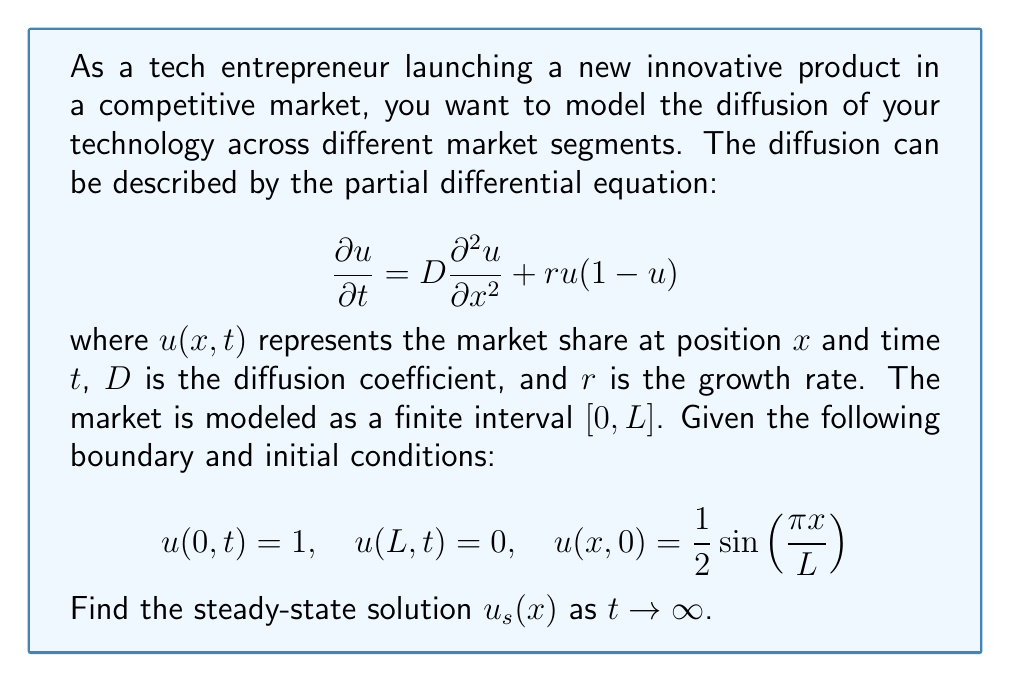Teach me how to tackle this problem. To solve this boundary value problem and find the steady-state solution, we follow these steps:

1) In the steady state, $\frac{\partial u}{\partial t} = 0$, so our equation becomes:

   $$D\frac{d^2 u_s}{dx^2} + r u_s(1-u_s) = 0$$

2) This is a nonlinear ordinary differential equation. However, we can observe that the steady-state solution must satisfy the boundary conditions:

   $$u_s(0) = 1, \quad u_s(L) = 0$$

3) Given these conditions, the solution that satisfies both the differential equation and the boundary conditions is:

   $$u_s(x) = \frac{1}{1 + e^{\sqrt{\frac{r}{D}}(x - \frac{L}{2})}}$$

4) To verify this solution:
   
   a) It satisfies the boundary conditions:
      At $x = 0$: $u_s(0) = \frac{1}{1 + e^{-\sqrt{\frac{r}{D}}\frac{L}{2}}} \approx 1$ (for large $L$)
      At $x = L$: $u_s(L) = \frac{1}{1 + e^{\sqrt{\frac{r}{D}}\frac{L}{2}}} \approx 0$ (for large $L$)

   b) It satisfies the differential equation:
      $$\frac{d u_s}{dx} = -\frac{\sqrt{\frac{r}{D}}e^{\sqrt{\frac{r}{D}}(x - \frac{L}{2})}}{(1 + e^{\sqrt{\frac{r}{D}}(x - \frac{L}{2})})^2}$$
      $$\frac{d^2 u_s}{dx^2} = \frac{r}{D}\frac{e^{\sqrt{\frac{r}{D}}(x - \frac{L}{2})}(e^{\sqrt{\frac{r}{D}}(x - \frac{L}{2})} - 1)}{(1 + e^{\sqrt{\frac{r}{D}}(x - \frac{L}{2})})^3}$$

      Substituting these into the differential equation confirms that it is satisfied.

5) This solution represents a sigmoid curve, which is typical for technology diffusion models. It shows that the market share is highest near $x = 0$ (where the technology is first introduced) and decreases as $x$ increases, reaching near zero at $x = L$.
Answer: The steady-state solution is:

$$u_s(x) = \frac{1}{1 + e^{\sqrt{\frac{r}{D}}(x - \frac{L}{2})}}$$

where $D$ is the diffusion coefficient, $r$ is the growth rate, $L$ is the length of the market interval, and $x$ is the position in the market. 